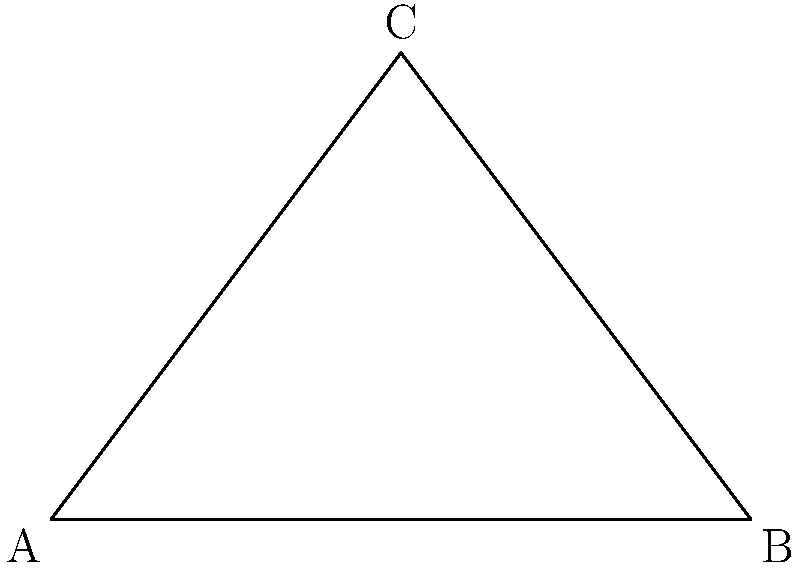A digital billboard is positioned at point C on a building, 4 meters above street level. The street extends from point A to B, with a total length of 6 meters. If the optimal viewing angle is achieved when the billboard is perpendicular to the line of sight, at what distance from point A should a viewer stand to have the best view of the billboard? To find the optimal viewing position, we need to determine where the line of sight is perpendicular to the billboard. This occurs when the viewer's position forms a right angle with points A and C.

Let's approach this step-by-step:

1) In the right triangle ACX (where X is the optimal viewing position):
   - The height (AC) is 4 meters
   - The base (AX) is what we're trying to find
   - The hypotenuse (CX) is the line of sight

2) In a right triangle, the angle between the hypotenuse and the longer leg is 30°. This means the angle CAX must be 60° (as the three angles in a triangle sum to 180°).

3) In a 30-60-90 triangle, the ratio of sides is 1 : √3 : 2
   - The shorter leg (AC) corresponds to 1
   - The longer leg (AX) corresponds to √3
   - The hypotenuse (CX) corresponds to 2

4) Since AC = 4 meters, and this corresponds to 1 in the ratio, we can set up the proportion:

   $\frac{AX}{4} = \frac{\sqrt{3}}{1}$

5) Solving for AX:
   $AX = 4\sqrt{3}$ meters

Therefore, the optimal viewing position is $4\sqrt{3}$ meters from point A.
Answer: $4\sqrt{3}$ meters from A 